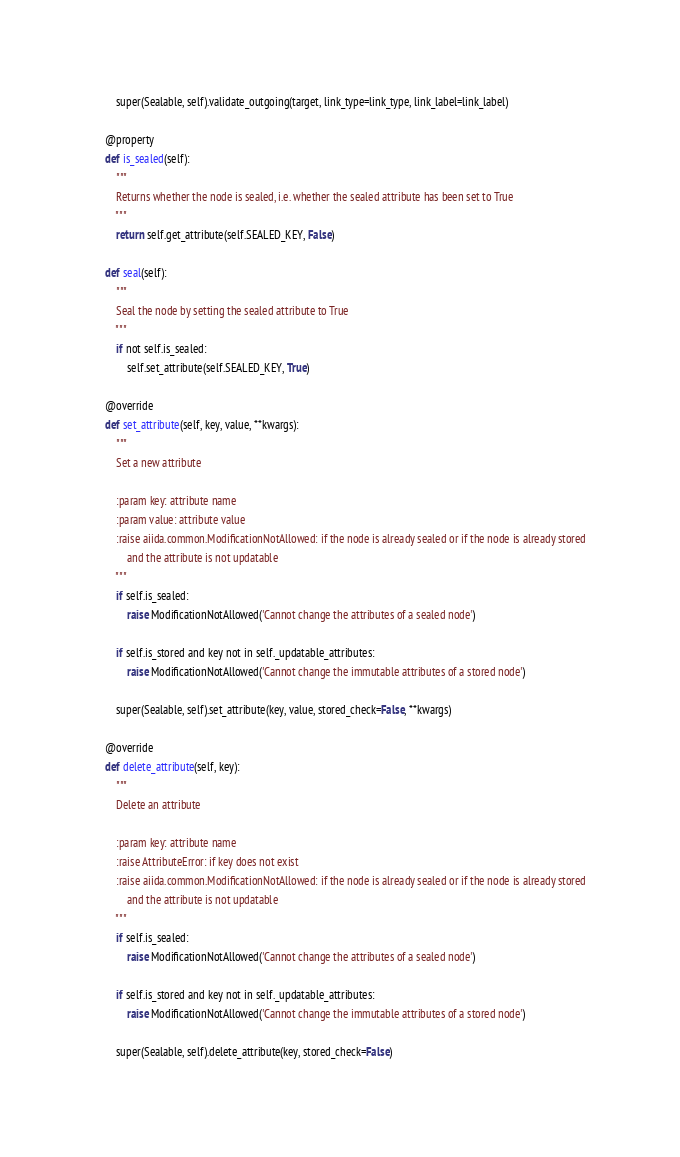<code> <loc_0><loc_0><loc_500><loc_500><_Python_>        super(Sealable, self).validate_outgoing(target, link_type=link_type, link_label=link_label)

    @property
    def is_sealed(self):
        """
        Returns whether the node is sealed, i.e. whether the sealed attribute has been set to True
        """
        return self.get_attribute(self.SEALED_KEY, False)

    def seal(self):
        """
        Seal the node by setting the sealed attribute to True
        """
        if not self.is_sealed:
            self.set_attribute(self.SEALED_KEY, True)

    @override
    def set_attribute(self, key, value, **kwargs):
        """
        Set a new attribute

        :param key: attribute name
        :param value: attribute value
        :raise aiida.common.ModificationNotAllowed: if the node is already sealed or if the node is already stored
            and the attribute is not updatable
        """
        if self.is_sealed:
            raise ModificationNotAllowed('Cannot change the attributes of a sealed node')

        if self.is_stored and key not in self._updatable_attributes:
            raise ModificationNotAllowed('Cannot change the immutable attributes of a stored node')

        super(Sealable, self).set_attribute(key, value, stored_check=False, **kwargs)

    @override
    def delete_attribute(self, key):
        """
        Delete an attribute

        :param key: attribute name
        :raise AttributeError: if key does not exist
        :raise aiida.common.ModificationNotAllowed: if the node is already sealed or if the node is already stored
            and the attribute is not updatable
        """
        if self.is_sealed:
            raise ModificationNotAllowed('Cannot change the attributes of a sealed node')

        if self.is_stored and key not in self._updatable_attributes:
            raise ModificationNotAllowed('Cannot change the immutable attributes of a stored node')

        super(Sealable, self).delete_attribute(key, stored_check=False)
</code> 